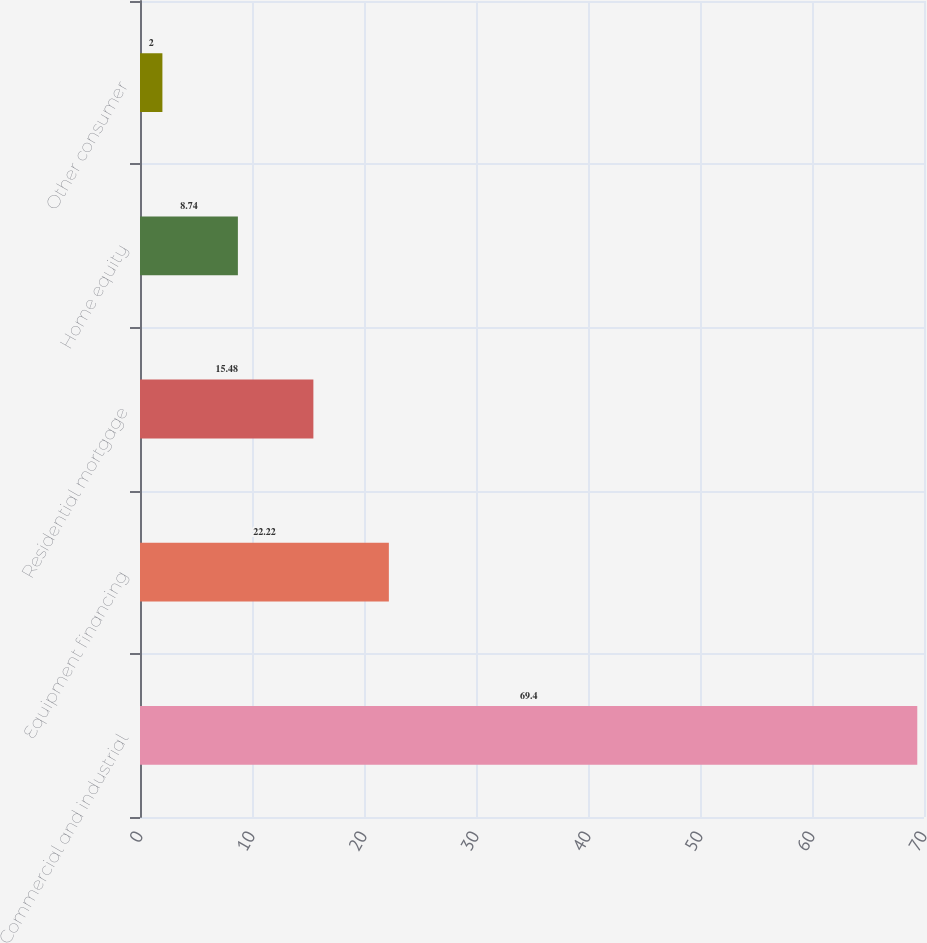<chart> <loc_0><loc_0><loc_500><loc_500><bar_chart><fcel>Commercial and industrial<fcel>Equipment financing<fcel>Residential mortgage<fcel>Home equity<fcel>Other consumer<nl><fcel>69.4<fcel>22.22<fcel>15.48<fcel>8.74<fcel>2<nl></chart> 